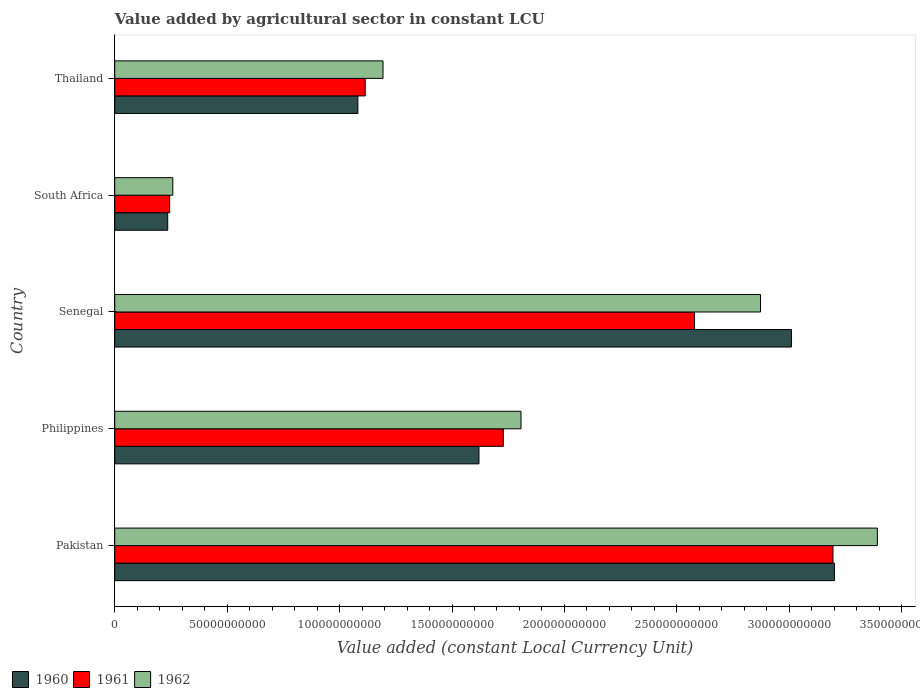How many groups of bars are there?
Provide a succinct answer. 5. Are the number of bars per tick equal to the number of legend labels?
Provide a succinct answer. Yes. Are the number of bars on each tick of the Y-axis equal?
Offer a terse response. Yes. How many bars are there on the 1st tick from the bottom?
Your answer should be very brief. 3. What is the label of the 3rd group of bars from the top?
Ensure brevity in your answer.  Senegal. In how many cases, is the number of bars for a given country not equal to the number of legend labels?
Offer a very short reply. 0. What is the value added by agricultural sector in 1962 in Thailand?
Your response must be concise. 1.19e+11. Across all countries, what is the maximum value added by agricultural sector in 1961?
Your response must be concise. 3.19e+11. Across all countries, what is the minimum value added by agricultural sector in 1961?
Give a very brief answer. 2.44e+1. In which country was the value added by agricultural sector in 1961 maximum?
Your response must be concise. Pakistan. In which country was the value added by agricultural sector in 1960 minimum?
Your answer should be compact. South Africa. What is the total value added by agricultural sector in 1961 in the graph?
Keep it short and to the point. 8.86e+11. What is the difference between the value added by agricultural sector in 1960 in Senegal and that in Thailand?
Keep it short and to the point. 1.93e+11. What is the difference between the value added by agricultural sector in 1960 in Pakistan and the value added by agricultural sector in 1962 in Senegal?
Your answer should be very brief. 3.29e+1. What is the average value added by agricultural sector in 1961 per country?
Your answer should be compact. 1.77e+11. What is the difference between the value added by agricultural sector in 1961 and value added by agricultural sector in 1960 in Senegal?
Provide a succinct answer. -4.31e+1. What is the ratio of the value added by agricultural sector in 1960 in Senegal to that in Thailand?
Your answer should be compact. 2.78. Is the value added by agricultural sector in 1961 in Pakistan less than that in South Africa?
Provide a short and direct response. No. What is the difference between the highest and the second highest value added by agricultural sector in 1961?
Your answer should be compact. 6.16e+1. What is the difference between the highest and the lowest value added by agricultural sector in 1962?
Your answer should be very brief. 3.13e+11. In how many countries, is the value added by agricultural sector in 1962 greater than the average value added by agricultural sector in 1962 taken over all countries?
Your answer should be compact. 2. Is the sum of the value added by agricultural sector in 1962 in Senegal and Thailand greater than the maximum value added by agricultural sector in 1961 across all countries?
Provide a succinct answer. Yes. What does the 3rd bar from the top in Philippines represents?
Ensure brevity in your answer.  1960. Are all the bars in the graph horizontal?
Your answer should be very brief. Yes. How many countries are there in the graph?
Keep it short and to the point. 5. Are the values on the major ticks of X-axis written in scientific E-notation?
Give a very brief answer. No. Does the graph contain grids?
Keep it short and to the point. No. How many legend labels are there?
Your answer should be compact. 3. What is the title of the graph?
Give a very brief answer. Value added by agricultural sector in constant LCU. Does "2012" appear as one of the legend labels in the graph?
Offer a very short reply. No. What is the label or title of the X-axis?
Give a very brief answer. Value added (constant Local Currency Unit). What is the label or title of the Y-axis?
Offer a terse response. Country. What is the Value added (constant Local Currency Unit) in 1960 in Pakistan?
Keep it short and to the point. 3.20e+11. What is the Value added (constant Local Currency Unit) of 1961 in Pakistan?
Provide a succinct answer. 3.19e+11. What is the Value added (constant Local Currency Unit) in 1962 in Pakistan?
Make the answer very short. 3.39e+11. What is the Value added (constant Local Currency Unit) in 1960 in Philippines?
Give a very brief answer. 1.62e+11. What is the Value added (constant Local Currency Unit) in 1961 in Philippines?
Provide a succinct answer. 1.73e+11. What is the Value added (constant Local Currency Unit) in 1962 in Philippines?
Provide a succinct answer. 1.81e+11. What is the Value added (constant Local Currency Unit) in 1960 in Senegal?
Your answer should be compact. 3.01e+11. What is the Value added (constant Local Currency Unit) in 1961 in Senegal?
Ensure brevity in your answer.  2.58e+11. What is the Value added (constant Local Currency Unit) in 1962 in Senegal?
Offer a terse response. 2.87e+11. What is the Value added (constant Local Currency Unit) of 1960 in South Africa?
Provide a succinct answer. 2.36e+1. What is the Value added (constant Local Currency Unit) of 1961 in South Africa?
Ensure brevity in your answer.  2.44e+1. What is the Value added (constant Local Currency Unit) in 1962 in South Africa?
Make the answer very short. 2.58e+1. What is the Value added (constant Local Currency Unit) in 1960 in Thailand?
Keep it short and to the point. 1.08e+11. What is the Value added (constant Local Currency Unit) of 1961 in Thailand?
Keep it short and to the point. 1.11e+11. What is the Value added (constant Local Currency Unit) in 1962 in Thailand?
Provide a succinct answer. 1.19e+11. Across all countries, what is the maximum Value added (constant Local Currency Unit) in 1960?
Ensure brevity in your answer.  3.20e+11. Across all countries, what is the maximum Value added (constant Local Currency Unit) of 1961?
Give a very brief answer. 3.19e+11. Across all countries, what is the maximum Value added (constant Local Currency Unit) of 1962?
Provide a succinct answer. 3.39e+11. Across all countries, what is the minimum Value added (constant Local Currency Unit) of 1960?
Provide a short and direct response. 2.36e+1. Across all countries, what is the minimum Value added (constant Local Currency Unit) of 1961?
Offer a terse response. 2.44e+1. Across all countries, what is the minimum Value added (constant Local Currency Unit) in 1962?
Your answer should be compact. 2.58e+1. What is the total Value added (constant Local Currency Unit) of 1960 in the graph?
Your response must be concise. 9.15e+11. What is the total Value added (constant Local Currency Unit) of 1961 in the graph?
Offer a terse response. 8.86e+11. What is the total Value added (constant Local Currency Unit) in 1962 in the graph?
Offer a very short reply. 9.52e+11. What is the difference between the Value added (constant Local Currency Unit) in 1960 in Pakistan and that in Philippines?
Offer a very short reply. 1.58e+11. What is the difference between the Value added (constant Local Currency Unit) in 1961 in Pakistan and that in Philippines?
Provide a succinct answer. 1.47e+11. What is the difference between the Value added (constant Local Currency Unit) in 1962 in Pakistan and that in Philippines?
Provide a short and direct response. 1.58e+11. What is the difference between the Value added (constant Local Currency Unit) in 1960 in Pakistan and that in Senegal?
Provide a succinct answer. 1.91e+1. What is the difference between the Value added (constant Local Currency Unit) in 1961 in Pakistan and that in Senegal?
Your answer should be compact. 6.16e+1. What is the difference between the Value added (constant Local Currency Unit) of 1962 in Pakistan and that in Senegal?
Provide a succinct answer. 5.20e+1. What is the difference between the Value added (constant Local Currency Unit) of 1960 in Pakistan and that in South Africa?
Your answer should be compact. 2.97e+11. What is the difference between the Value added (constant Local Currency Unit) in 1961 in Pakistan and that in South Africa?
Give a very brief answer. 2.95e+11. What is the difference between the Value added (constant Local Currency Unit) of 1962 in Pakistan and that in South Africa?
Provide a short and direct response. 3.13e+11. What is the difference between the Value added (constant Local Currency Unit) of 1960 in Pakistan and that in Thailand?
Make the answer very short. 2.12e+11. What is the difference between the Value added (constant Local Currency Unit) in 1961 in Pakistan and that in Thailand?
Provide a short and direct response. 2.08e+11. What is the difference between the Value added (constant Local Currency Unit) in 1962 in Pakistan and that in Thailand?
Provide a short and direct response. 2.20e+11. What is the difference between the Value added (constant Local Currency Unit) of 1960 in Philippines and that in Senegal?
Give a very brief answer. -1.39e+11. What is the difference between the Value added (constant Local Currency Unit) in 1961 in Philippines and that in Senegal?
Give a very brief answer. -8.50e+1. What is the difference between the Value added (constant Local Currency Unit) in 1962 in Philippines and that in Senegal?
Offer a terse response. -1.07e+11. What is the difference between the Value added (constant Local Currency Unit) of 1960 in Philippines and that in South Africa?
Offer a terse response. 1.38e+11. What is the difference between the Value added (constant Local Currency Unit) of 1961 in Philippines and that in South Africa?
Your answer should be very brief. 1.48e+11. What is the difference between the Value added (constant Local Currency Unit) of 1962 in Philippines and that in South Africa?
Offer a very short reply. 1.55e+11. What is the difference between the Value added (constant Local Currency Unit) of 1960 in Philippines and that in Thailand?
Offer a very short reply. 5.39e+1. What is the difference between the Value added (constant Local Currency Unit) of 1961 in Philippines and that in Thailand?
Provide a succinct answer. 6.14e+1. What is the difference between the Value added (constant Local Currency Unit) in 1962 in Philippines and that in Thailand?
Ensure brevity in your answer.  6.14e+1. What is the difference between the Value added (constant Local Currency Unit) in 1960 in Senegal and that in South Africa?
Provide a short and direct response. 2.77e+11. What is the difference between the Value added (constant Local Currency Unit) in 1961 in Senegal and that in South Africa?
Give a very brief answer. 2.33e+11. What is the difference between the Value added (constant Local Currency Unit) of 1962 in Senegal and that in South Africa?
Ensure brevity in your answer.  2.61e+11. What is the difference between the Value added (constant Local Currency Unit) of 1960 in Senegal and that in Thailand?
Provide a short and direct response. 1.93e+11. What is the difference between the Value added (constant Local Currency Unit) in 1961 in Senegal and that in Thailand?
Give a very brief answer. 1.46e+11. What is the difference between the Value added (constant Local Currency Unit) in 1962 in Senegal and that in Thailand?
Ensure brevity in your answer.  1.68e+11. What is the difference between the Value added (constant Local Currency Unit) of 1960 in South Africa and that in Thailand?
Provide a short and direct response. -8.46e+1. What is the difference between the Value added (constant Local Currency Unit) in 1961 in South Africa and that in Thailand?
Ensure brevity in your answer.  -8.70e+1. What is the difference between the Value added (constant Local Currency Unit) of 1962 in South Africa and that in Thailand?
Make the answer very short. -9.35e+1. What is the difference between the Value added (constant Local Currency Unit) of 1960 in Pakistan and the Value added (constant Local Currency Unit) of 1961 in Philippines?
Offer a terse response. 1.47e+11. What is the difference between the Value added (constant Local Currency Unit) in 1960 in Pakistan and the Value added (constant Local Currency Unit) in 1962 in Philippines?
Provide a succinct answer. 1.39e+11. What is the difference between the Value added (constant Local Currency Unit) of 1961 in Pakistan and the Value added (constant Local Currency Unit) of 1962 in Philippines?
Offer a very short reply. 1.39e+11. What is the difference between the Value added (constant Local Currency Unit) of 1960 in Pakistan and the Value added (constant Local Currency Unit) of 1961 in Senegal?
Your answer should be compact. 6.22e+1. What is the difference between the Value added (constant Local Currency Unit) of 1960 in Pakistan and the Value added (constant Local Currency Unit) of 1962 in Senegal?
Your answer should be very brief. 3.29e+1. What is the difference between the Value added (constant Local Currency Unit) in 1961 in Pakistan and the Value added (constant Local Currency Unit) in 1962 in Senegal?
Ensure brevity in your answer.  3.22e+1. What is the difference between the Value added (constant Local Currency Unit) of 1960 in Pakistan and the Value added (constant Local Currency Unit) of 1961 in South Africa?
Your answer should be very brief. 2.96e+11. What is the difference between the Value added (constant Local Currency Unit) in 1960 in Pakistan and the Value added (constant Local Currency Unit) in 1962 in South Africa?
Keep it short and to the point. 2.94e+11. What is the difference between the Value added (constant Local Currency Unit) of 1961 in Pakistan and the Value added (constant Local Currency Unit) of 1962 in South Africa?
Offer a terse response. 2.94e+11. What is the difference between the Value added (constant Local Currency Unit) in 1960 in Pakistan and the Value added (constant Local Currency Unit) in 1961 in Thailand?
Provide a succinct answer. 2.09e+11. What is the difference between the Value added (constant Local Currency Unit) of 1960 in Pakistan and the Value added (constant Local Currency Unit) of 1962 in Thailand?
Provide a short and direct response. 2.01e+11. What is the difference between the Value added (constant Local Currency Unit) in 1961 in Pakistan and the Value added (constant Local Currency Unit) in 1962 in Thailand?
Provide a succinct answer. 2.00e+11. What is the difference between the Value added (constant Local Currency Unit) of 1960 in Philippines and the Value added (constant Local Currency Unit) of 1961 in Senegal?
Your response must be concise. -9.59e+1. What is the difference between the Value added (constant Local Currency Unit) in 1960 in Philippines and the Value added (constant Local Currency Unit) in 1962 in Senegal?
Provide a short and direct response. -1.25e+11. What is the difference between the Value added (constant Local Currency Unit) of 1961 in Philippines and the Value added (constant Local Currency Unit) of 1962 in Senegal?
Offer a terse response. -1.14e+11. What is the difference between the Value added (constant Local Currency Unit) in 1960 in Philippines and the Value added (constant Local Currency Unit) in 1961 in South Africa?
Make the answer very short. 1.38e+11. What is the difference between the Value added (constant Local Currency Unit) of 1960 in Philippines and the Value added (constant Local Currency Unit) of 1962 in South Africa?
Provide a succinct answer. 1.36e+11. What is the difference between the Value added (constant Local Currency Unit) in 1961 in Philippines and the Value added (constant Local Currency Unit) in 1962 in South Africa?
Your answer should be compact. 1.47e+11. What is the difference between the Value added (constant Local Currency Unit) of 1960 in Philippines and the Value added (constant Local Currency Unit) of 1961 in Thailand?
Your answer should be very brief. 5.06e+1. What is the difference between the Value added (constant Local Currency Unit) in 1960 in Philippines and the Value added (constant Local Currency Unit) in 1962 in Thailand?
Offer a terse response. 4.27e+1. What is the difference between the Value added (constant Local Currency Unit) of 1961 in Philippines and the Value added (constant Local Currency Unit) of 1962 in Thailand?
Offer a terse response. 5.35e+1. What is the difference between the Value added (constant Local Currency Unit) in 1960 in Senegal and the Value added (constant Local Currency Unit) in 1961 in South Africa?
Keep it short and to the point. 2.77e+11. What is the difference between the Value added (constant Local Currency Unit) of 1960 in Senegal and the Value added (constant Local Currency Unit) of 1962 in South Africa?
Provide a succinct answer. 2.75e+11. What is the difference between the Value added (constant Local Currency Unit) in 1961 in Senegal and the Value added (constant Local Currency Unit) in 1962 in South Africa?
Make the answer very short. 2.32e+11. What is the difference between the Value added (constant Local Currency Unit) in 1960 in Senegal and the Value added (constant Local Currency Unit) in 1961 in Thailand?
Your response must be concise. 1.90e+11. What is the difference between the Value added (constant Local Currency Unit) in 1960 in Senegal and the Value added (constant Local Currency Unit) in 1962 in Thailand?
Provide a succinct answer. 1.82e+11. What is the difference between the Value added (constant Local Currency Unit) of 1961 in Senegal and the Value added (constant Local Currency Unit) of 1962 in Thailand?
Your response must be concise. 1.39e+11. What is the difference between the Value added (constant Local Currency Unit) in 1960 in South Africa and the Value added (constant Local Currency Unit) in 1961 in Thailand?
Provide a short and direct response. -8.78e+1. What is the difference between the Value added (constant Local Currency Unit) in 1960 in South Africa and the Value added (constant Local Currency Unit) in 1962 in Thailand?
Make the answer very short. -9.58e+1. What is the difference between the Value added (constant Local Currency Unit) of 1961 in South Africa and the Value added (constant Local Currency Unit) of 1962 in Thailand?
Your answer should be very brief. -9.49e+1. What is the average Value added (constant Local Currency Unit) in 1960 per country?
Your answer should be compact. 1.83e+11. What is the average Value added (constant Local Currency Unit) of 1961 per country?
Offer a terse response. 1.77e+11. What is the average Value added (constant Local Currency Unit) in 1962 per country?
Your answer should be very brief. 1.90e+11. What is the difference between the Value added (constant Local Currency Unit) in 1960 and Value added (constant Local Currency Unit) in 1961 in Pakistan?
Offer a very short reply. 6.46e+08. What is the difference between the Value added (constant Local Currency Unit) in 1960 and Value added (constant Local Currency Unit) in 1962 in Pakistan?
Offer a very short reply. -1.91e+1. What is the difference between the Value added (constant Local Currency Unit) in 1961 and Value added (constant Local Currency Unit) in 1962 in Pakistan?
Your answer should be compact. -1.97e+1. What is the difference between the Value added (constant Local Currency Unit) of 1960 and Value added (constant Local Currency Unit) of 1961 in Philippines?
Ensure brevity in your answer.  -1.08e+1. What is the difference between the Value added (constant Local Currency Unit) of 1960 and Value added (constant Local Currency Unit) of 1962 in Philippines?
Keep it short and to the point. -1.87e+1. What is the difference between the Value added (constant Local Currency Unit) in 1961 and Value added (constant Local Currency Unit) in 1962 in Philippines?
Your response must be concise. -7.86e+09. What is the difference between the Value added (constant Local Currency Unit) in 1960 and Value added (constant Local Currency Unit) in 1961 in Senegal?
Provide a short and direct response. 4.31e+1. What is the difference between the Value added (constant Local Currency Unit) of 1960 and Value added (constant Local Currency Unit) of 1962 in Senegal?
Provide a succinct answer. 1.38e+1. What is the difference between the Value added (constant Local Currency Unit) of 1961 and Value added (constant Local Currency Unit) of 1962 in Senegal?
Provide a short and direct response. -2.93e+1. What is the difference between the Value added (constant Local Currency Unit) of 1960 and Value added (constant Local Currency Unit) of 1961 in South Africa?
Ensure brevity in your answer.  -8.75e+08. What is the difference between the Value added (constant Local Currency Unit) in 1960 and Value added (constant Local Currency Unit) in 1962 in South Africa?
Offer a very short reply. -2.26e+09. What is the difference between the Value added (constant Local Currency Unit) in 1961 and Value added (constant Local Currency Unit) in 1962 in South Africa?
Your response must be concise. -1.39e+09. What is the difference between the Value added (constant Local Currency Unit) in 1960 and Value added (constant Local Currency Unit) in 1961 in Thailand?
Your answer should be compact. -3.26e+09. What is the difference between the Value added (constant Local Currency Unit) of 1960 and Value added (constant Local Currency Unit) of 1962 in Thailand?
Provide a short and direct response. -1.12e+1. What is the difference between the Value added (constant Local Currency Unit) of 1961 and Value added (constant Local Currency Unit) of 1962 in Thailand?
Your response must be concise. -7.93e+09. What is the ratio of the Value added (constant Local Currency Unit) of 1960 in Pakistan to that in Philippines?
Keep it short and to the point. 1.98. What is the ratio of the Value added (constant Local Currency Unit) of 1961 in Pakistan to that in Philippines?
Your answer should be compact. 1.85. What is the ratio of the Value added (constant Local Currency Unit) in 1962 in Pakistan to that in Philippines?
Make the answer very short. 1.88. What is the ratio of the Value added (constant Local Currency Unit) of 1960 in Pakistan to that in Senegal?
Provide a succinct answer. 1.06. What is the ratio of the Value added (constant Local Currency Unit) in 1961 in Pakistan to that in Senegal?
Offer a terse response. 1.24. What is the ratio of the Value added (constant Local Currency Unit) of 1962 in Pakistan to that in Senegal?
Keep it short and to the point. 1.18. What is the ratio of the Value added (constant Local Currency Unit) of 1960 in Pakistan to that in South Africa?
Provide a succinct answer. 13.59. What is the ratio of the Value added (constant Local Currency Unit) of 1961 in Pakistan to that in South Africa?
Your answer should be very brief. 13.07. What is the ratio of the Value added (constant Local Currency Unit) in 1962 in Pakistan to that in South Africa?
Provide a succinct answer. 13.14. What is the ratio of the Value added (constant Local Currency Unit) in 1960 in Pakistan to that in Thailand?
Offer a terse response. 2.96. What is the ratio of the Value added (constant Local Currency Unit) of 1961 in Pakistan to that in Thailand?
Make the answer very short. 2.87. What is the ratio of the Value added (constant Local Currency Unit) in 1962 in Pakistan to that in Thailand?
Your response must be concise. 2.84. What is the ratio of the Value added (constant Local Currency Unit) of 1960 in Philippines to that in Senegal?
Provide a succinct answer. 0.54. What is the ratio of the Value added (constant Local Currency Unit) in 1961 in Philippines to that in Senegal?
Provide a succinct answer. 0.67. What is the ratio of the Value added (constant Local Currency Unit) in 1962 in Philippines to that in Senegal?
Ensure brevity in your answer.  0.63. What is the ratio of the Value added (constant Local Currency Unit) of 1960 in Philippines to that in South Africa?
Your answer should be compact. 6.88. What is the ratio of the Value added (constant Local Currency Unit) of 1961 in Philippines to that in South Africa?
Your answer should be very brief. 7.07. What is the ratio of the Value added (constant Local Currency Unit) of 1962 in Philippines to that in South Africa?
Offer a terse response. 7. What is the ratio of the Value added (constant Local Currency Unit) of 1960 in Philippines to that in Thailand?
Offer a terse response. 1.5. What is the ratio of the Value added (constant Local Currency Unit) in 1961 in Philippines to that in Thailand?
Your response must be concise. 1.55. What is the ratio of the Value added (constant Local Currency Unit) in 1962 in Philippines to that in Thailand?
Provide a short and direct response. 1.51. What is the ratio of the Value added (constant Local Currency Unit) of 1960 in Senegal to that in South Africa?
Provide a succinct answer. 12.77. What is the ratio of the Value added (constant Local Currency Unit) in 1961 in Senegal to that in South Africa?
Your answer should be compact. 10.55. What is the ratio of the Value added (constant Local Currency Unit) of 1962 in Senegal to that in South Africa?
Keep it short and to the point. 11.12. What is the ratio of the Value added (constant Local Currency Unit) in 1960 in Senegal to that in Thailand?
Ensure brevity in your answer.  2.78. What is the ratio of the Value added (constant Local Currency Unit) in 1961 in Senegal to that in Thailand?
Keep it short and to the point. 2.31. What is the ratio of the Value added (constant Local Currency Unit) in 1962 in Senegal to that in Thailand?
Provide a succinct answer. 2.41. What is the ratio of the Value added (constant Local Currency Unit) of 1960 in South Africa to that in Thailand?
Provide a succinct answer. 0.22. What is the ratio of the Value added (constant Local Currency Unit) of 1961 in South Africa to that in Thailand?
Provide a short and direct response. 0.22. What is the ratio of the Value added (constant Local Currency Unit) in 1962 in South Africa to that in Thailand?
Your response must be concise. 0.22. What is the difference between the highest and the second highest Value added (constant Local Currency Unit) of 1960?
Your answer should be very brief. 1.91e+1. What is the difference between the highest and the second highest Value added (constant Local Currency Unit) of 1961?
Ensure brevity in your answer.  6.16e+1. What is the difference between the highest and the second highest Value added (constant Local Currency Unit) in 1962?
Provide a short and direct response. 5.20e+1. What is the difference between the highest and the lowest Value added (constant Local Currency Unit) in 1960?
Provide a short and direct response. 2.97e+11. What is the difference between the highest and the lowest Value added (constant Local Currency Unit) in 1961?
Keep it short and to the point. 2.95e+11. What is the difference between the highest and the lowest Value added (constant Local Currency Unit) in 1962?
Provide a short and direct response. 3.13e+11. 